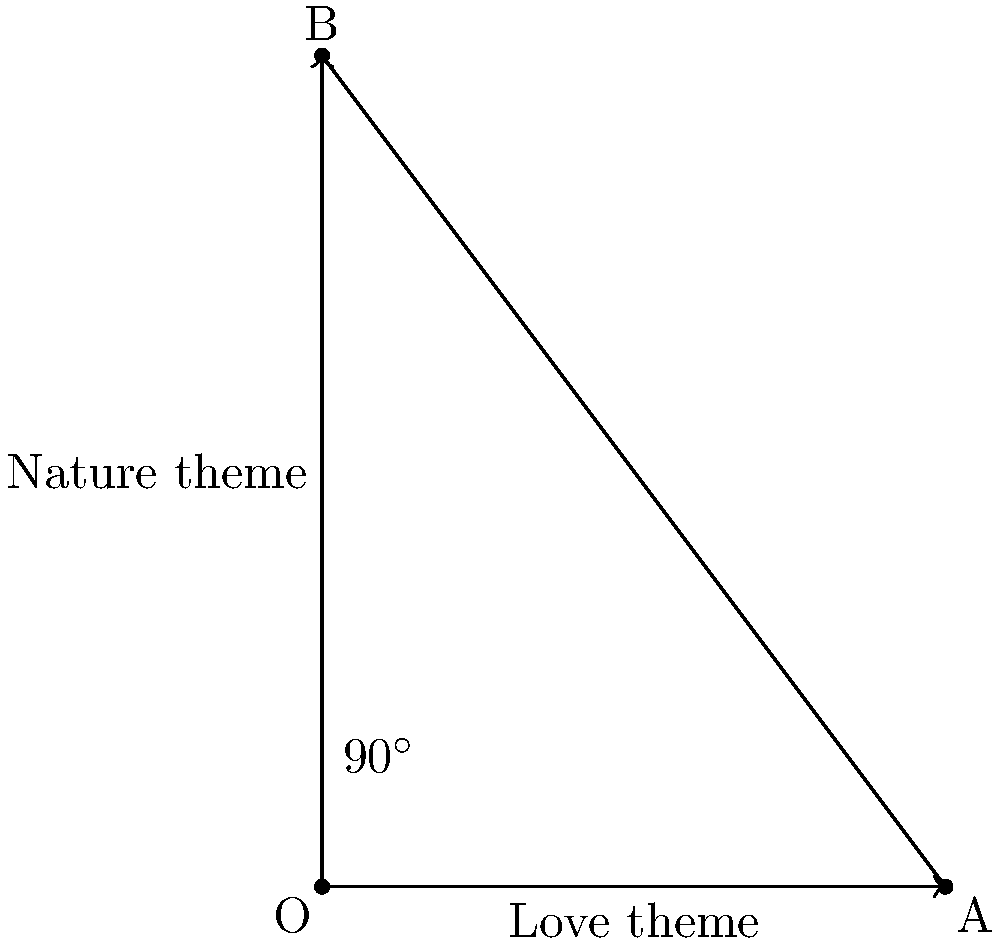In analyzing the thematic structure of Shakespeare's sonnets and Sidney's "Astrophil and Stella," we can represent major themes as vectors. If the "love" theme is represented by vector $\vec{a} = \langle 3, 0 \rangle$ and the "nature" theme by vector $\vec{b} = \langle 0, 4 \rangle$, how can we use the cross product to determine if these themes are orthogonal (perpendicular) in their treatment across the two sonnet sequences? To determine if two vectors are orthogonal using the cross product, we can follow these steps:

1) Recall that two vectors are orthogonal if their dot product is zero.

2) The cross product of two 2D vectors $\vec{a} = \langle a_1, a_2 \rangle$ and $\vec{b} = \langle b_1, b_2 \rangle$ is defined as:

   $\vec{a} \times \vec{b} = a_1b_2 - a_2b_1$

3) If the magnitude of the cross product equals the product of the magnitudes of the two vectors, then the vectors are orthogonal:

   $|\vec{a} \times \vec{b}| = |\vec{a}| \cdot |\vec{b}|$

4) For our vectors:
   $\vec{a} = \langle 3, 0 \rangle$ and $\vec{b} = \langle 0, 4 \rangle$

5) Calculate the cross product:
   $\vec{a} \times \vec{b} = (3)(4) - (0)(0) = 12$

6) Calculate the magnitudes:
   $|\vec{a}| = \sqrt{3^2 + 0^2} = 3$
   $|\vec{b}| = \sqrt{0^2 + 4^2} = 4$

7) Compare:
   $|\vec{a} \times \vec{b}| = 12$
   $|\vec{a}| \cdot |\vec{b}| = 3 \cdot 4 = 12$

8) Since these are equal, the vectors are orthogonal.

This orthogonality suggests that the treatment of love and nature themes in these sonnet sequences are independent or perpendicular in their poetic space, indicating distinct and separate explorations of these themes.
Answer: $|\vec{a} \times \vec{b}| = |\vec{a}| \cdot |\vec{b}| = 12$ 